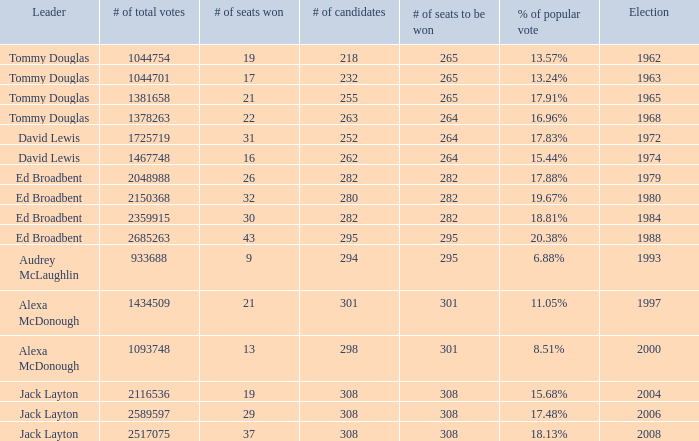Name the number of candidates for # of seats won being 43 295.0. Give me the full table as a dictionary. {'header': ['Leader', '# of total votes', '# of seats won', '# of candidates', '# of seats to be won', '% of popular vote', 'Election'], 'rows': [['Tommy Douglas', '1044754', '19', '218', '265', '13.57%', '1962'], ['Tommy Douglas', '1044701', '17', '232', '265', '13.24%', '1963'], ['Tommy Douglas', '1381658', '21', '255', '265', '17.91%', '1965'], ['Tommy Douglas', '1378263', '22', '263', '264', '16.96%', '1968'], ['David Lewis', '1725719', '31', '252', '264', '17.83%', '1972'], ['David Lewis', '1467748', '16', '262', '264', '15.44%', '1974'], ['Ed Broadbent', '2048988', '26', '282', '282', '17.88%', '1979'], ['Ed Broadbent', '2150368', '32', '280', '282', '19.67%', '1980'], ['Ed Broadbent', '2359915', '30', '282', '282', '18.81%', '1984'], ['Ed Broadbent', '2685263', '43', '295', '295', '20.38%', '1988'], ['Audrey McLaughlin', '933688', '9', '294', '295', '6.88%', '1993'], ['Alexa McDonough', '1434509', '21', '301', '301', '11.05%', '1997'], ['Alexa McDonough', '1093748', '13', '298', '301', '8.51%', '2000'], ['Jack Layton', '2116536', '19', '308', '308', '15.68%', '2004'], ['Jack Layton', '2589597', '29', '308', '308', '17.48%', '2006'], ['Jack Layton', '2517075', '37', '308', '308', '18.13%', '2008']]} 